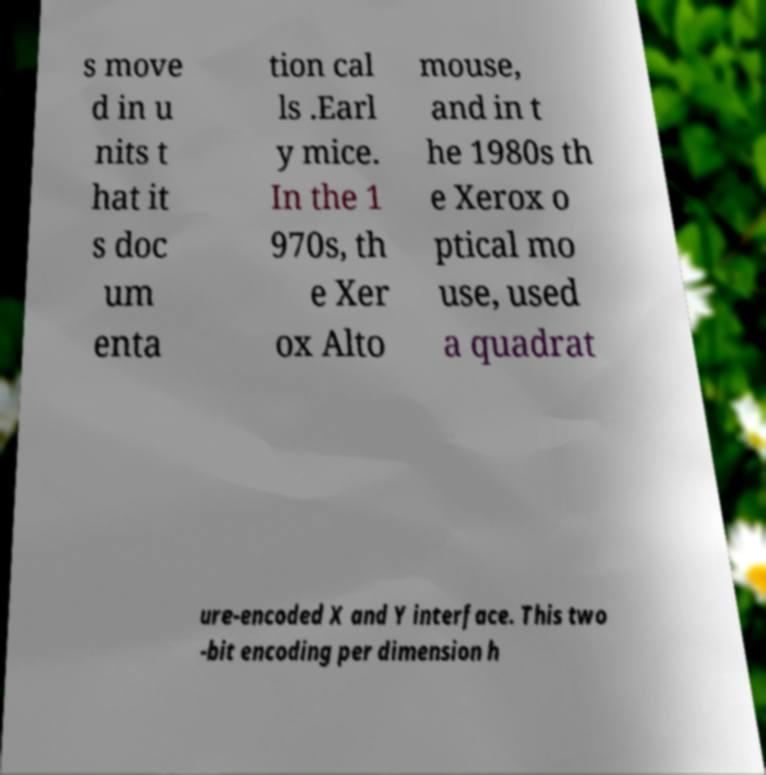Could you extract and type out the text from this image? s move d in u nits t hat it s doc um enta tion cal ls .Earl y mice. In the 1 970s, th e Xer ox Alto mouse, and in t he 1980s th e Xerox o ptical mo use, used a quadrat ure-encoded X and Y interface. This two -bit encoding per dimension h 